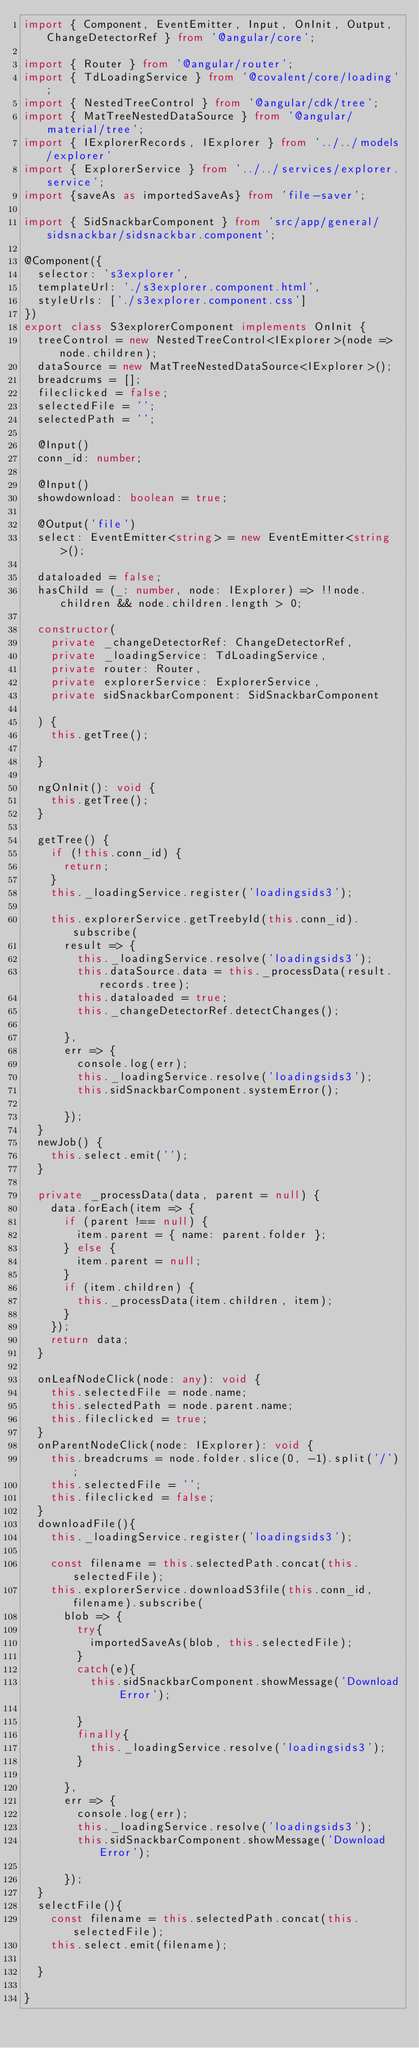Convert code to text. <code><loc_0><loc_0><loc_500><loc_500><_TypeScript_>import { Component, EventEmitter, Input, OnInit, Output, ChangeDetectorRef } from '@angular/core';

import { Router } from '@angular/router';
import { TdLoadingService } from '@covalent/core/loading';
import { NestedTreeControl } from '@angular/cdk/tree';
import { MatTreeNestedDataSource } from '@angular/material/tree';
import { IExplorerRecords, IExplorer } from '../../models/explorer'
import { ExplorerService } from '../../services/explorer.service';
import {saveAs as importedSaveAs} from 'file-saver';

import { SidSnackbarComponent } from 'src/app/general/sidsnackbar/sidsnackbar.component';

@Component({
  selector: 's3explorer',
  templateUrl: './s3explorer.component.html',
  styleUrls: ['./s3explorer.component.css']
})
export class S3explorerComponent implements OnInit {
  treeControl = new NestedTreeControl<IExplorer>(node => node.children);
  dataSource = new MatTreeNestedDataSource<IExplorer>();
  breadcrums = [];
  fileclicked = false;
  selectedFile = '';
  selectedPath = '';

  @Input()
  conn_id: number;

  @Input()
  showdownload: boolean = true;

  @Output('file')
  select: EventEmitter<string> = new EventEmitter<string>();

  dataloaded = false;
  hasChild = (_: number, node: IExplorer) => !!node.children && node.children.length > 0;

  constructor(
    private _changeDetectorRef: ChangeDetectorRef,
    private _loadingService: TdLoadingService,
    private router: Router,
    private explorerService: ExplorerService,
    private sidSnackbarComponent: SidSnackbarComponent

  ) {
    this.getTree();

  }

  ngOnInit(): void {
    this.getTree();
  }

  getTree() {
    if (!this.conn_id) {
      return;
    }
    this._loadingService.register('loadingsids3');

    this.explorerService.getTreebyId(this.conn_id).subscribe(
      result => {
        this._loadingService.resolve('loadingsids3');
        this.dataSource.data = this._processData(result.records.tree);
        this.dataloaded = true;
        this._changeDetectorRef.detectChanges();

      },
      err => {
        console.log(err);
        this._loadingService.resolve('loadingsids3');
        this.sidSnackbarComponent.systemError();

      });
  }
  newJob() {
    this.select.emit('');
  }

  private _processData(data, parent = null) {
    data.forEach(item => {
      if (parent !== null) {
        item.parent = { name: parent.folder };
      } else {
        item.parent = null;
      }
      if (item.children) {
        this._processData(item.children, item);
      }
    });
    return data;
  }

  onLeafNodeClick(node: any): void {
    this.selectedFile = node.name;
    this.selectedPath = node.parent.name;
    this.fileclicked = true;
  }
  onParentNodeClick(node: IExplorer): void {
    this.breadcrums = node.folder.slice(0, -1).split('/');
    this.selectedFile = '';
    this.fileclicked = false;
  }
  downloadFile(){
    this._loadingService.register('loadingsids3');

    const filename = this.selectedPath.concat(this.selectedFile);
    this.explorerService.downloadS3file(this.conn_id, filename).subscribe(
      blob => {
        try{
          importedSaveAs(blob, this.selectedFile);
        }
        catch(e){
          this.sidSnackbarComponent.showMessage('Download Error');

        }
        finally{
          this._loadingService.resolve('loadingsids3');
        }

      },
      err => {
        console.log(err);
        this._loadingService.resolve('loadingsids3');
        this.sidSnackbarComponent.showMessage('Download Error');

      });
  }
  selectFile(){
    const filename = this.selectedPath.concat(this.selectedFile);
    this.select.emit(filename);

  }

}
</code> 